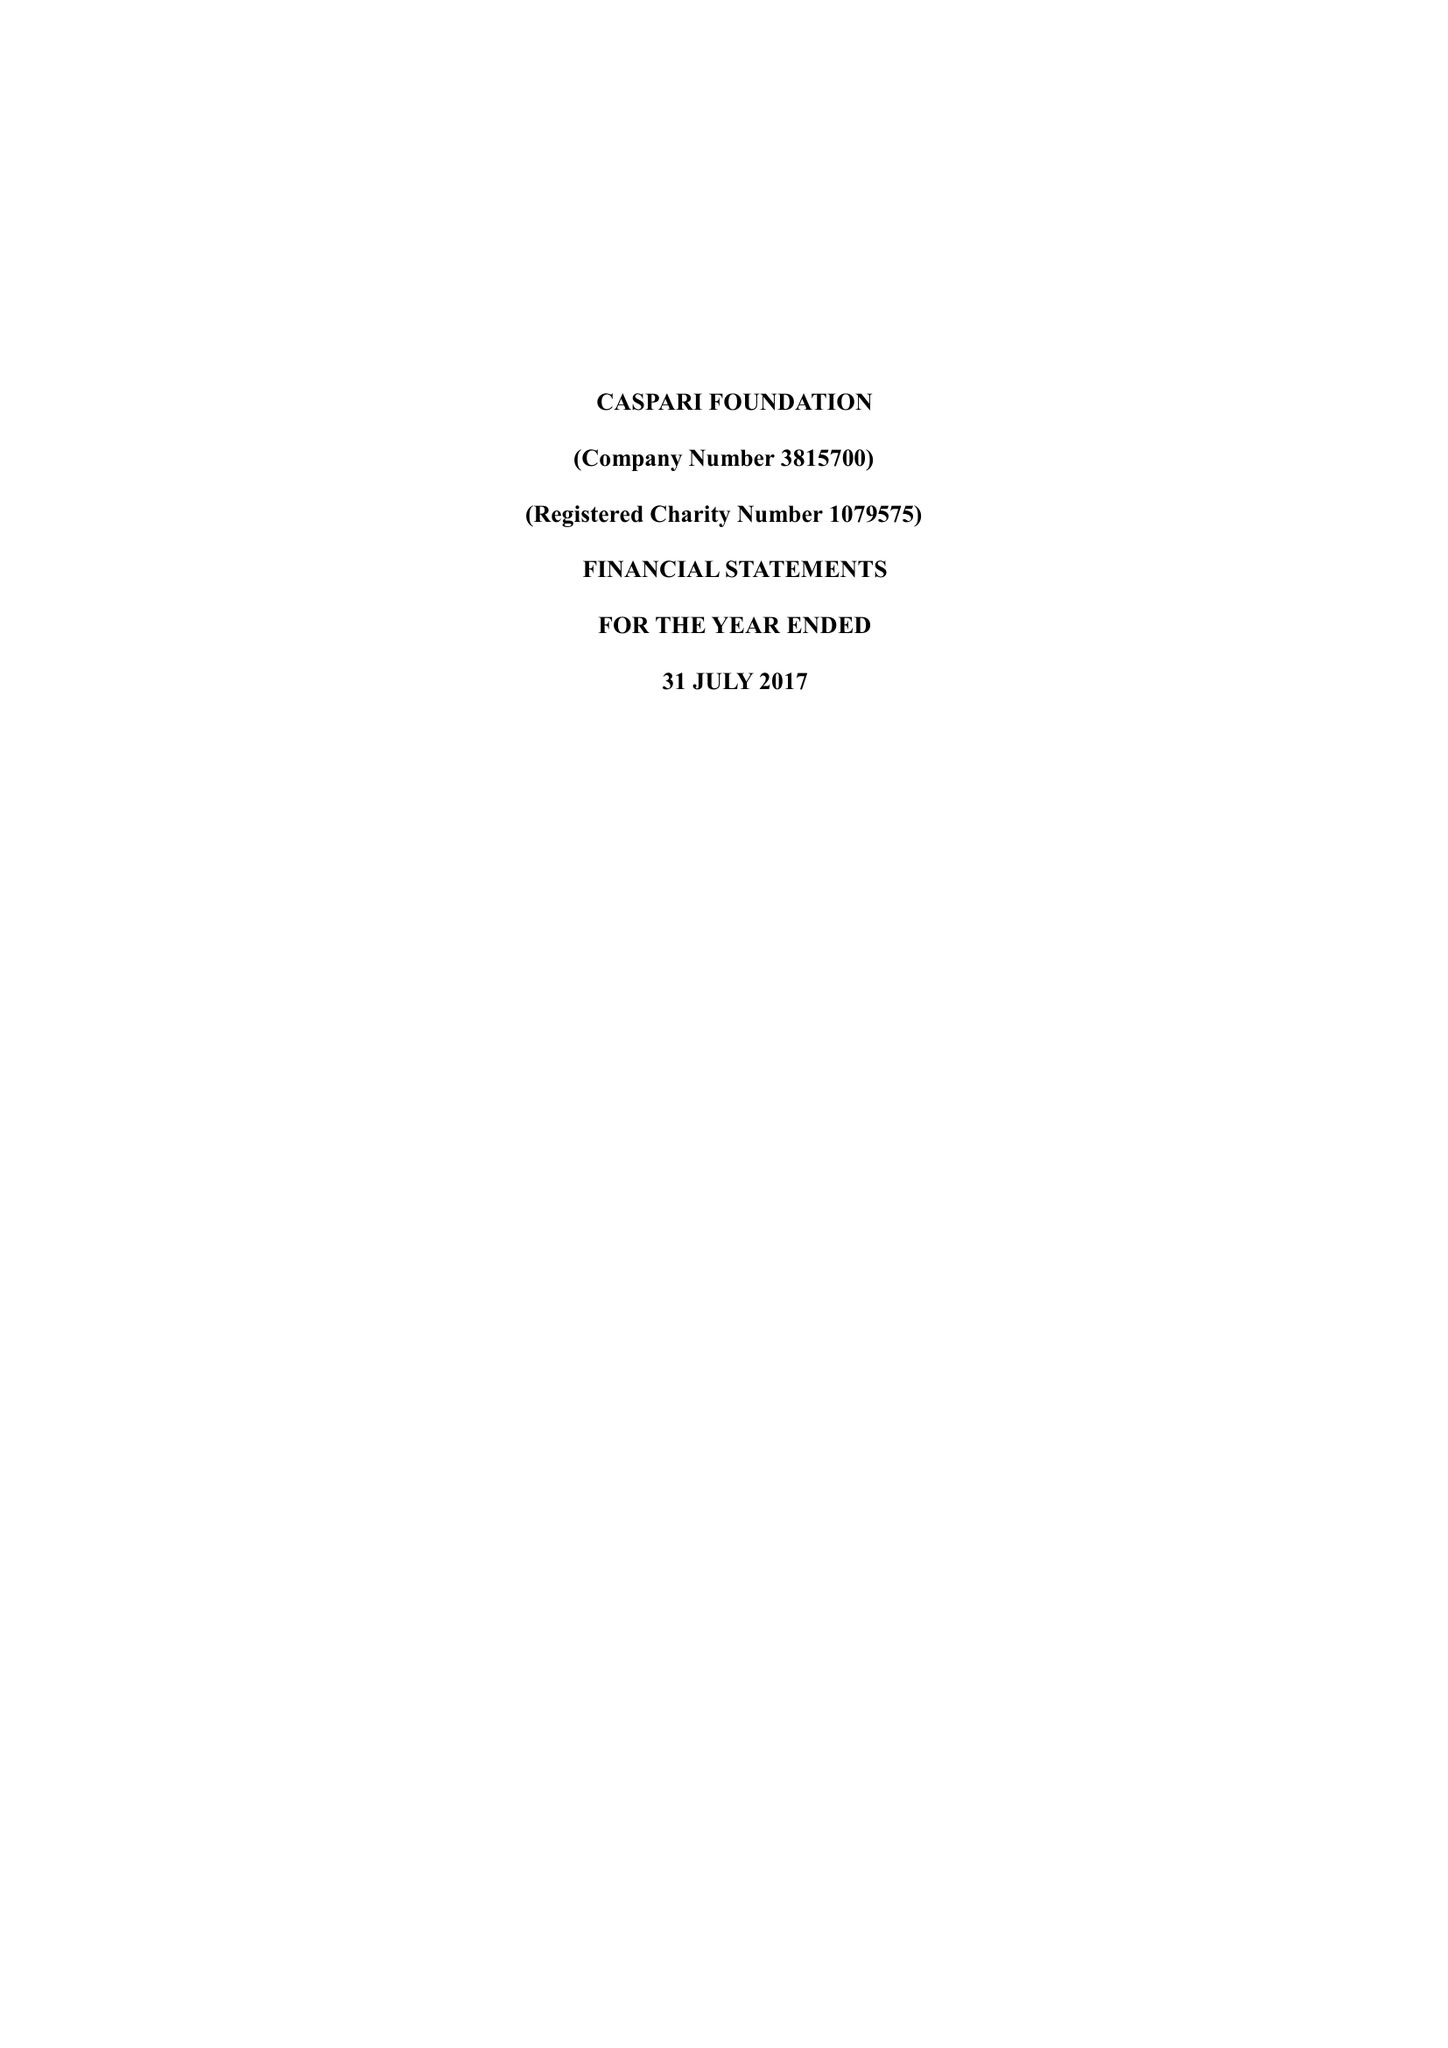What is the value for the address__postcode?
Answer the question using a single word or phrase. N4 2DA 